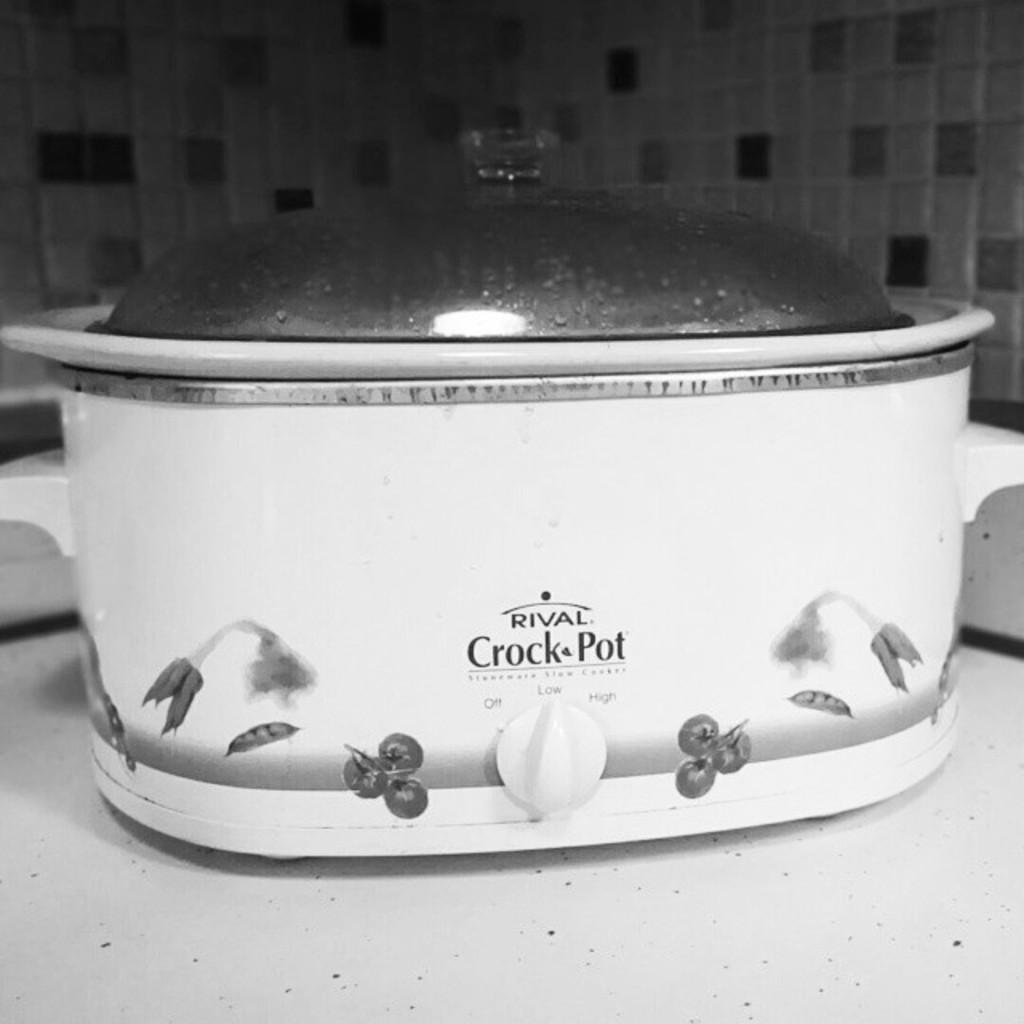<image>
Describe the image concisely. Rival Crock pot with tomato designs sitting on the counter. 